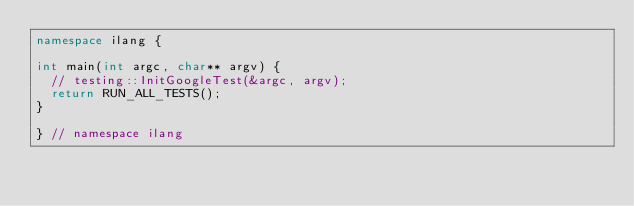<code> <loc_0><loc_0><loc_500><loc_500><_C++_>namespace ilang {

int main(int argc, char** argv) {
  // testing::InitGoogleTest(&argc, argv);
  return RUN_ALL_TESTS();
}

} // namespace ilang
</code> 